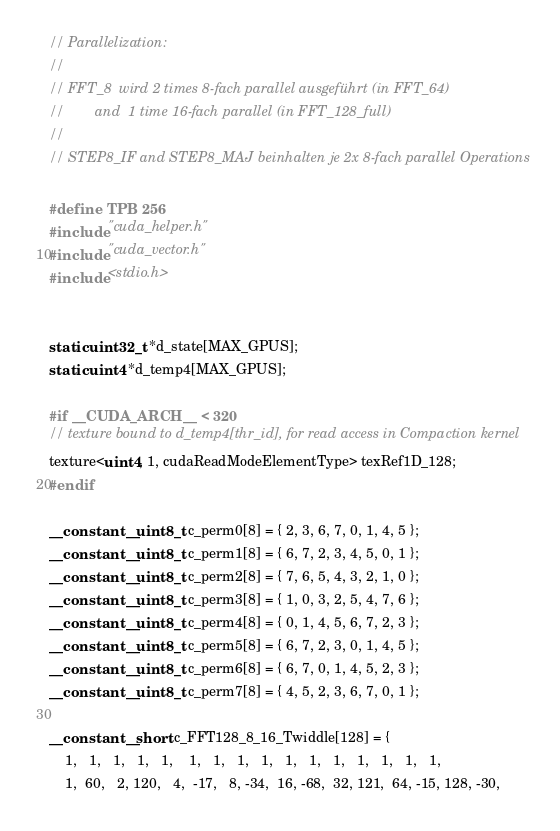<code> <loc_0><loc_0><loc_500><loc_500><_Cuda_>// Parallelization:
//
// FFT_8  wird 2 times 8-fach parallel ausgeführt (in FFT_64)
//        and  1 time 16-fach parallel (in FFT_128_full)
//
// STEP8_IF and STEP8_MAJ beinhalten je 2x 8-fach parallel Operations

#define TPB 256
#include "cuda_helper.h"
#include "cuda_vector.h"
#include <stdio.h>


static uint32_t *d_state[MAX_GPUS];
static uint4 *d_temp4[MAX_GPUS];

#if __CUDA_ARCH__ < 320
// texture bound to d_temp4[thr_id], for read access in Compaction kernel
texture<uint4, 1, cudaReadModeElementType> texRef1D_128;
#endif

__constant__ uint8_t c_perm0[8] = { 2, 3, 6, 7, 0, 1, 4, 5 };
__constant__ uint8_t c_perm1[8] = { 6, 7, 2, 3, 4, 5, 0, 1 };
__constant__ uint8_t c_perm2[8] = { 7, 6, 5, 4, 3, 2, 1, 0 };
__constant__ uint8_t c_perm3[8] = { 1, 0, 3, 2, 5, 4, 7, 6 };
__constant__ uint8_t c_perm4[8] = { 0, 1, 4, 5, 6, 7, 2, 3 };
__constant__ uint8_t c_perm5[8] = { 6, 7, 2, 3, 0, 1, 4, 5 };
__constant__ uint8_t c_perm6[8] = { 6, 7, 0, 1, 4, 5, 2, 3 };
__constant__ uint8_t c_perm7[8] = { 4, 5, 2, 3, 6, 7, 0, 1 };

__constant__ short c_FFT128_8_16_Twiddle[128] = {
	1,   1,   1,   1,   1,    1,   1,   1,   1,   1,   1,   1,   1,   1,   1,   1,
	1,  60,   2, 120,   4,  -17,   8, -34,  16, -68,  32, 121,  64, -15, 128, -30,</code> 